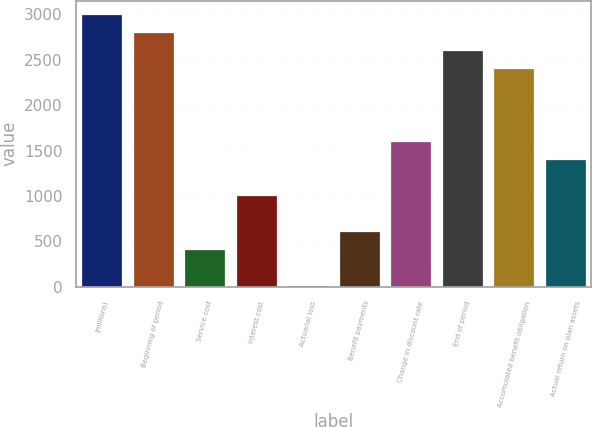Convert chart to OTSL. <chart><loc_0><loc_0><loc_500><loc_500><bar_chart><fcel>(millions)<fcel>Beginning of period<fcel>Service cost<fcel>Interest cost<fcel>Actuarial loss<fcel>Benefit payments<fcel>Change in discount rate<fcel>End of period<fcel>Accumulated benefit obligation<fcel>Actual return on plan assets<nl><fcel>3002.5<fcel>2803.4<fcel>414.2<fcel>1011.5<fcel>16<fcel>613.3<fcel>1608.8<fcel>2604.3<fcel>2405.2<fcel>1409.7<nl></chart> 